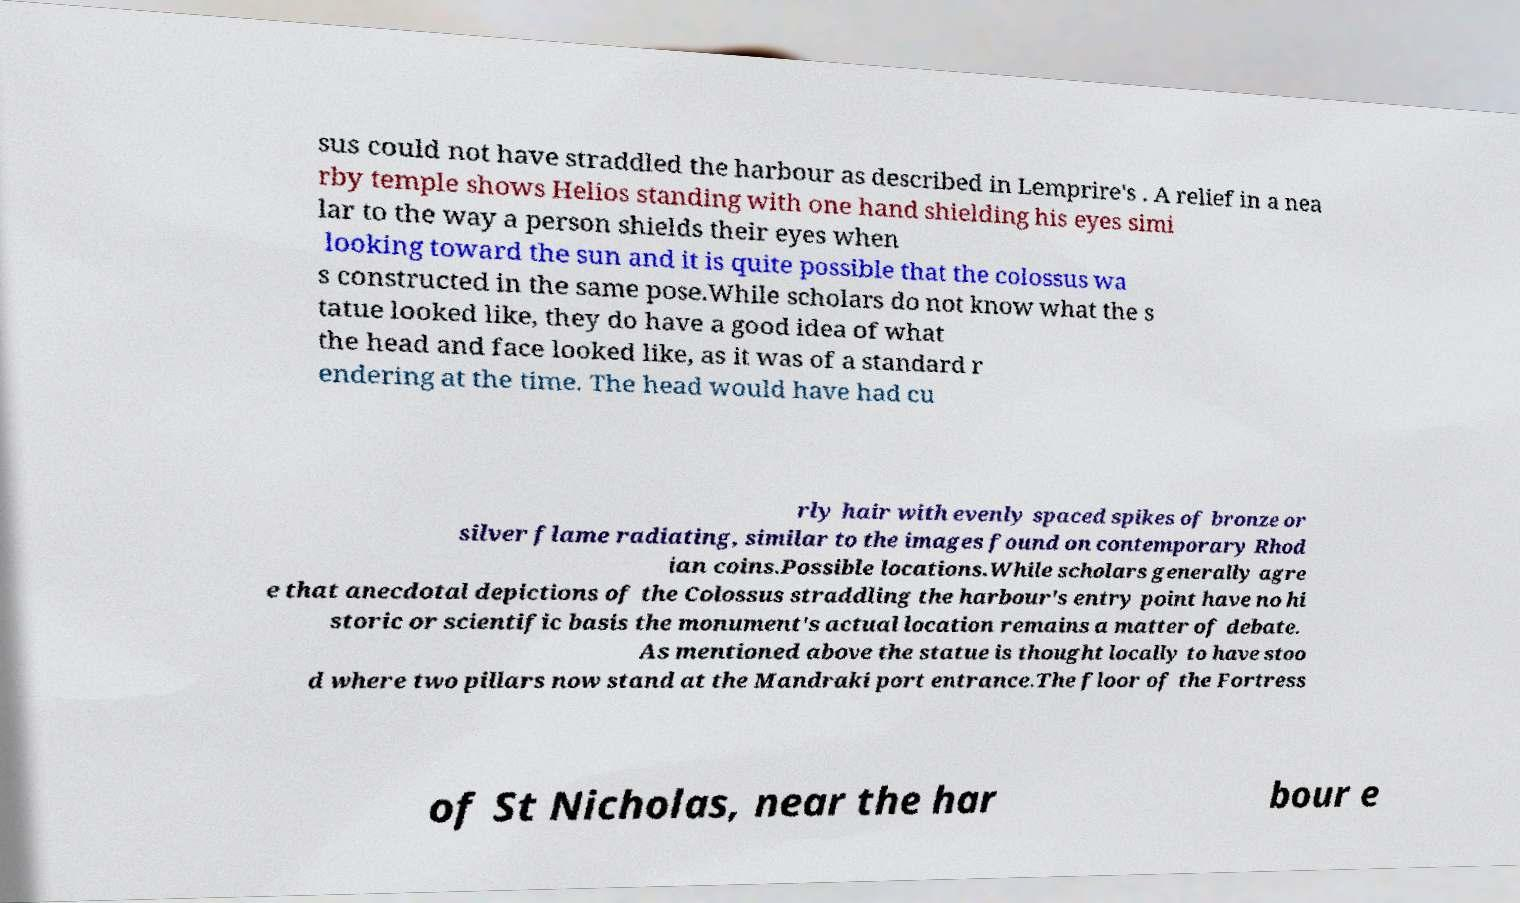What messages or text are displayed in this image? I need them in a readable, typed format. sus could not have straddled the harbour as described in Lemprire's . A relief in a nea rby temple shows Helios standing with one hand shielding his eyes simi lar to the way a person shields their eyes when looking toward the sun and it is quite possible that the colossus wa s constructed in the same pose.While scholars do not know what the s tatue looked like, they do have a good idea of what the head and face looked like, as it was of a standard r endering at the time. The head would have had cu rly hair with evenly spaced spikes of bronze or silver flame radiating, similar to the images found on contemporary Rhod ian coins.Possible locations.While scholars generally agre e that anecdotal depictions of the Colossus straddling the harbour's entry point have no hi storic or scientific basis the monument's actual location remains a matter of debate. As mentioned above the statue is thought locally to have stoo d where two pillars now stand at the Mandraki port entrance.The floor of the Fortress of St Nicholas, near the har bour e 